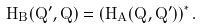<formula> <loc_0><loc_0><loc_500><loc_500>H _ { B } ( { { Q } ^ { \prime } } , Q ) = \left ( H _ { A } ( Q , { { Q } ^ { \prime } } ) \right ) ^ { * } .</formula> 